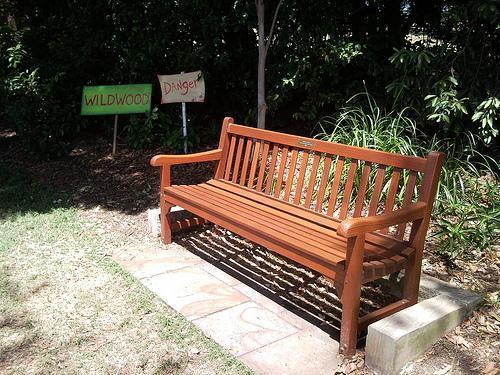How many signs are there?
Give a very brief answer. 2. 